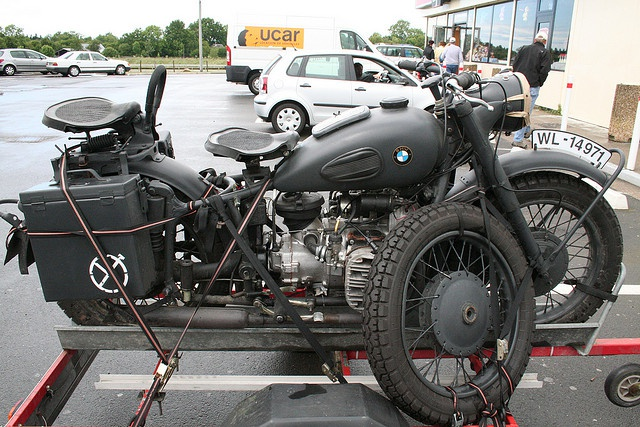Describe the objects in this image and their specific colors. I can see motorcycle in white, black, gray, darkgray, and lightgray tones, car in white, darkgray, black, and gray tones, truck in white, gold, gray, and darkgray tones, people in white, black, gray, lightgray, and darkgray tones, and car in white, black, darkgray, and gray tones in this image. 